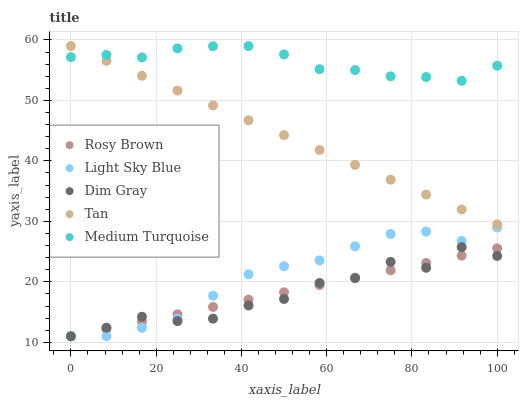Does Dim Gray have the minimum area under the curve?
Answer yes or no. Yes. Does Medium Turquoise have the maximum area under the curve?
Answer yes or no. Yes. Does Rosy Brown have the minimum area under the curve?
Answer yes or no. No. Does Rosy Brown have the maximum area under the curve?
Answer yes or no. No. Is Rosy Brown the smoothest?
Answer yes or no. Yes. Is Dim Gray the roughest?
Answer yes or no. Yes. Is Tan the smoothest?
Answer yes or no. No. Is Tan the roughest?
Answer yes or no. No. Does Dim Gray have the lowest value?
Answer yes or no. Yes. Does Tan have the lowest value?
Answer yes or no. No. Does Medium Turquoise have the highest value?
Answer yes or no. Yes. Does Rosy Brown have the highest value?
Answer yes or no. No. Is Rosy Brown less than Tan?
Answer yes or no. Yes. Is Medium Turquoise greater than Dim Gray?
Answer yes or no. Yes. Does Light Sky Blue intersect Rosy Brown?
Answer yes or no. Yes. Is Light Sky Blue less than Rosy Brown?
Answer yes or no. No. Is Light Sky Blue greater than Rosy Brown?
Answer yes or no. No. Does Rosy Brown intersect Tan?
Answer yes or no. No. 